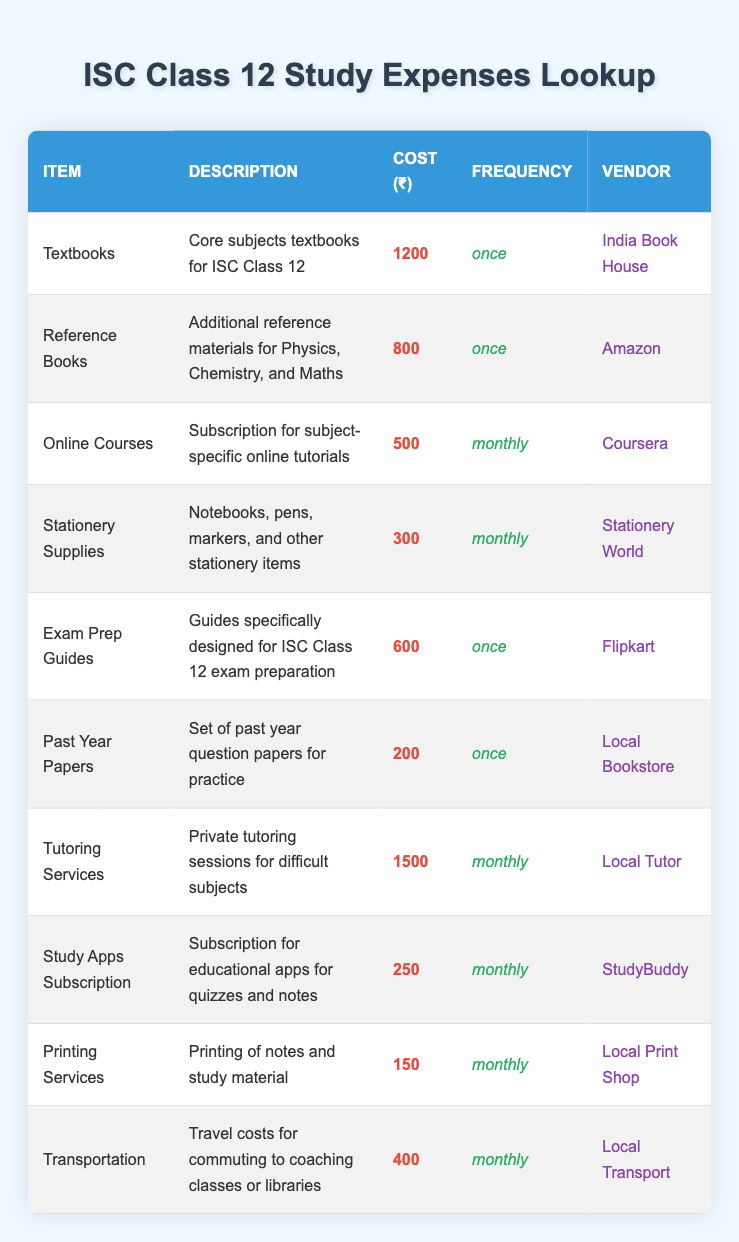What is the total cost for textbooks and reference books? The cost for textbooks is 1200 and for reference books is 800. Summing these gives 1200 + 800 = 2000.
Answer: 2000 How much do you spend monthly on stationery supplies? The table shows that the cost for stationery supplies is 300 and it occurs monthly. Therefore, the monthly cost is 300.
Answer: 300 Which vendor sells online courses? In the table, the vendor for online courses is listed as Coursera.
Answer: Coursera Is the cost for tutoring services higher than the combined costs of exam prep guides and past year papers? The cost for tutoring services is 1500. The cost for exam prep guides is 600 and for past year papers is 200. The combined cost of exam prep guides and past year papers is 600 + 200 = 800, which is less than 1500. So, yes, tutoring services cost more.
Answer: Yes What is the average monthly expense for all items that have a monthly frequency? The items with a monthly frequency are online courses (500), stationery supplies (300), tutoring services (1500), study apps subscription (250), printing services (150), and transportation (400). Their total is 500 + 300 + 1500 + 250 + 150 + 400 = 3100. There are 6 monthly items, so the average is 3100 / 6 = 516.67.
Answer: 516.67 How many items in the table have a one-time cost? In the table, items with a one-time cost are textbooks, reference books, exam prep guides, and past year papers. This counts to a total of 4 items.
Answer: 4 What is the total monthly expense calculated for all monthly expenses? The monthly expenses are online courses (500), stationery supplies (300), tutoring services (1500), study apps subscription (250), printing services (150), and transportation (400). Their total is 500 + 300 + 1500 + 250 + 150 + 400 = 3100.
Answer: 3100 Do all items listed in the table cost more than 100? Examining the costs: textbooks (1200), reference books (800), online courses (500), stationery supplies (300), exam prep guides (600), past year papers (200), tutoring services (1500), study apps subscription (250), printing services (150), and transportation (400). Past year papers costs only 200, which is not more than 100. Therefore, the statement is false.
Answer: No What is the most expensive item from the list and how much does it cost? The item with the highest cost is tutoring services at 1500.
Answer: Tutoring services at 1500 